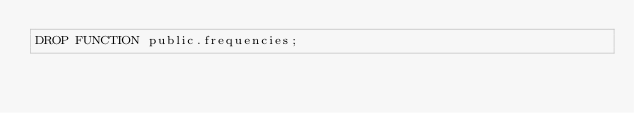Convert code to text. <code><loc_0><loc_0><loc_500><loc_500><_SQL_>DROP FUNCTION public.frequencies;
</code> 